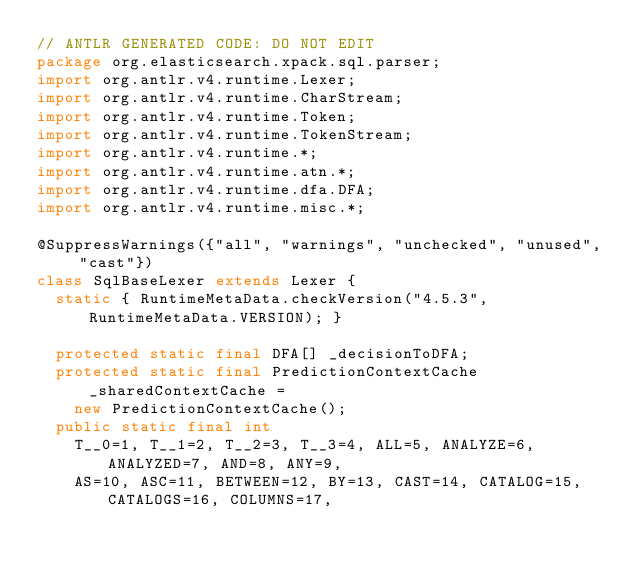<code> <loc_0><loc_0><loc_500><loc_500><_Java_>// ANTLR GENERATED CODE: DO NOT EDIT
package org.elasticsearch.xpack.sql.parser;
import org.antlr.v4.runtime.Lexer;
import org.antlr.v4.runtime.CharStream;
import org.antlr.v4.runtime.Token;
import org.antlr.v4.runtime.TokenStream;
import org.antlr.v4.runtime.*;
import org.antlr.v4.runtime.atn.*;
import org.antlr.v4.runtime.dfa.DFA;
import org.antlr.v4.runtime.misc.*;

@SuppressWarnings({"all", "warnings", "unchecked", "unused", "cast"})
class SqlBaseLexer extends Lexer {
  static { RuntimeMetaData.checkVersion("4.5.3", RuntimeMetaData.VERSION); }

  protected static final DFA[] _decisionToDFA;
  protected static final PredictionContextCache _sharedContextCache =
    new PredictionContextCache();
  public static final int
    T__0=1, T__1=2, T__2=3, T__3=4, ALL=5, ANALYZE=6, ANALYZED=7, AND=8, ANY=9, 
    AS=10, ASC=11, BETWEEN=12, BY=13, CAST=14, CATALOG=15, CATALOGS=16, COLUMNS=17, </code> 